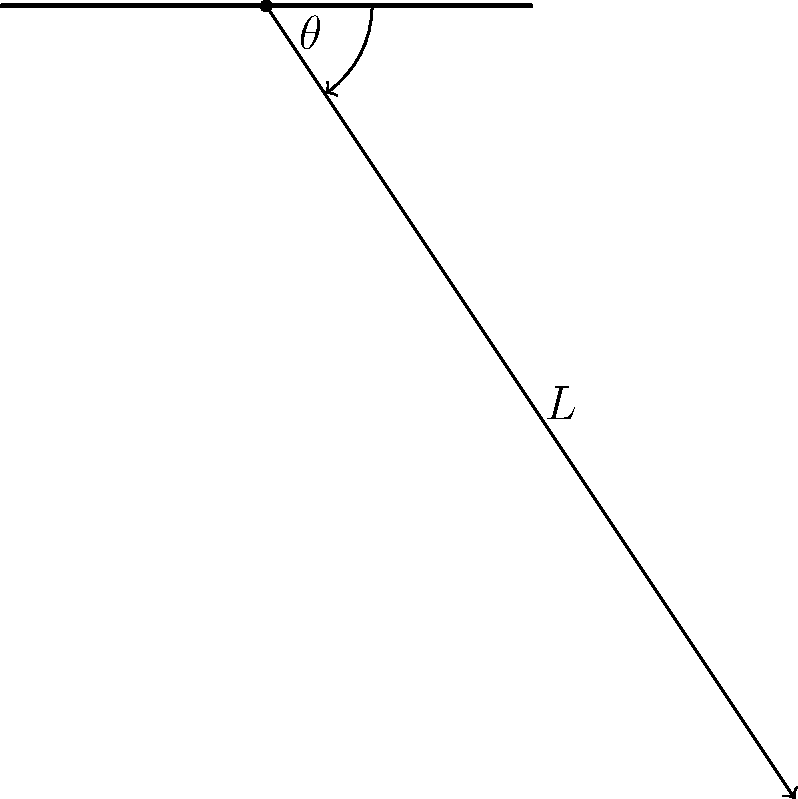Write a Python function `calculate_period(L, theta)` that calculates the period of a simple pendulum given its length $L$ (in meters) and initial angular displacement $\theta$ (in radians). Use the small-angle approximation formula: $T = 2\pi\sqrt{\frac{L}{g}}$, where $g = 9.81 \text{ m/s}^2$ is the acceleration due to gravity. Round the result to three decimal places. To solve this problem, we'll follow these steps:

1. Import the necessary module:
   We need the `math` module for the square root and pi functions.

2. Define the function with two parameters:
   `def calculate_period(L, theta):`

3. Implement the formula:
   The small-angle approximation formula is $T = 2\pi\sqrt{\frac{L}{g}}$
   where $g = 9.81 \text{ m/s}^2$

4. Calculate the period:
   `period = 2 * math.pi * math.sqrt(L / 9.81)`

5. Round the result to three decimal places:
   `return round(period, 3)`

The complete function would look like this:

```python
import math

def calculate_period(L, theta):
    period = 2 * math.pi * math.sqrt(L / 9.81)
    return round(period, 3)
```

Note that although we include $\theta$ as a parameter, it's not used in the small-angle approximation formula. This parameter could be useful for future extensions of the function that might include the effect of larger angles.
Answer: ```python
import math

def calculate_period(L, theta):
    return round(2 * math.pi * math.sqrt(L / 9.81), 3)
``` 